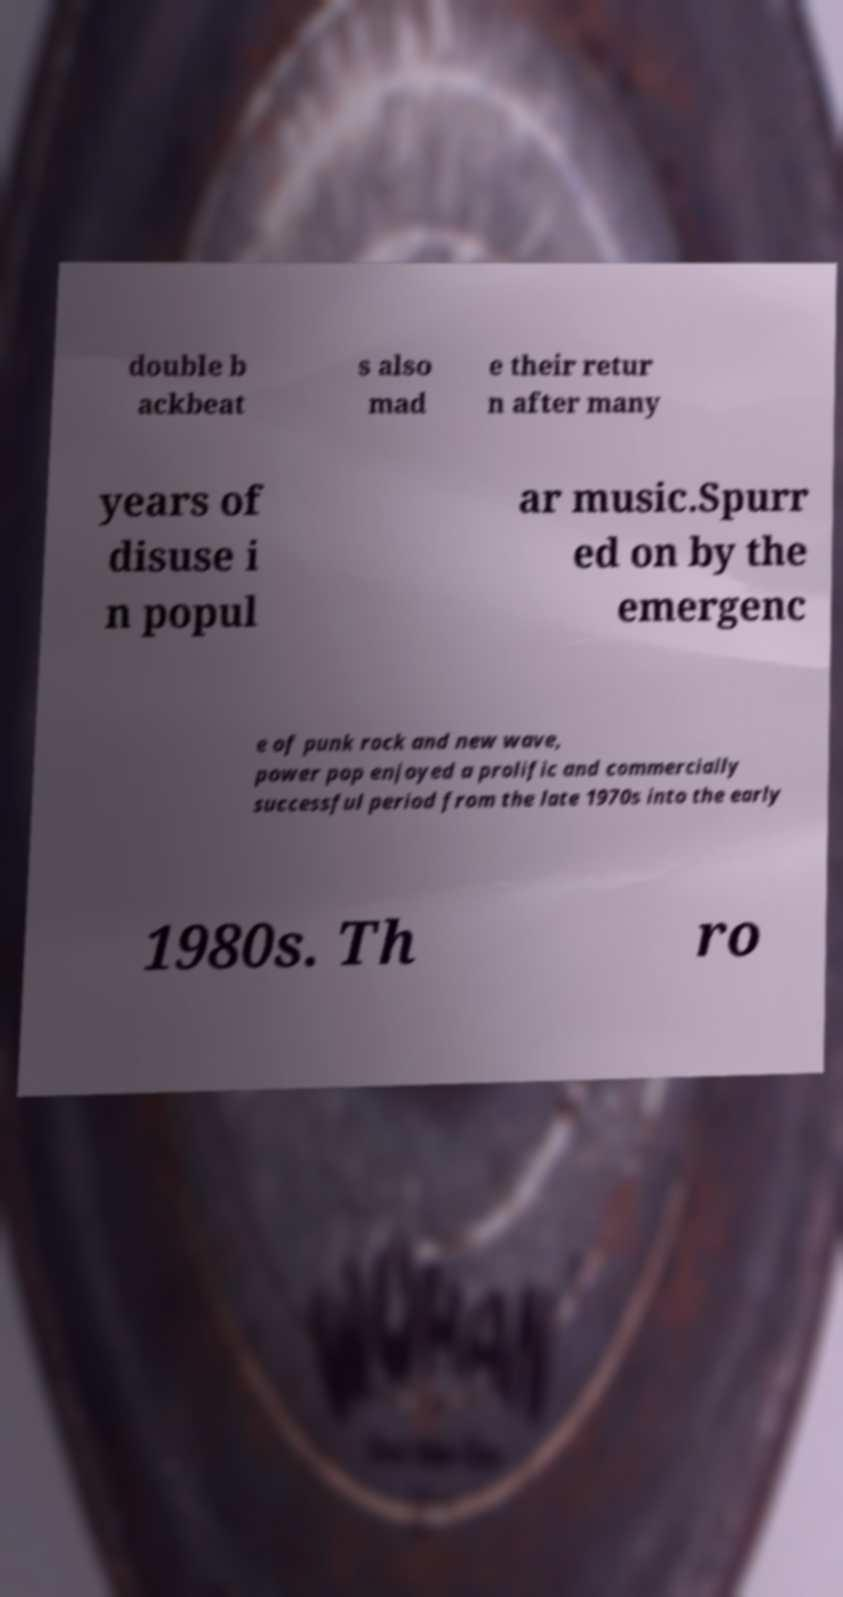For documentation purposes, I need the text within this image transcribed. Could you provide that? double b ackbeat s also mad e their retur n after many years of disuse i n popul ar music.Spurr ed on by the emergenc e of punk rock and new wave, power pop enjoyed a prolific and commercially successful period from the late 1970s into the early 1980s. Th ro 